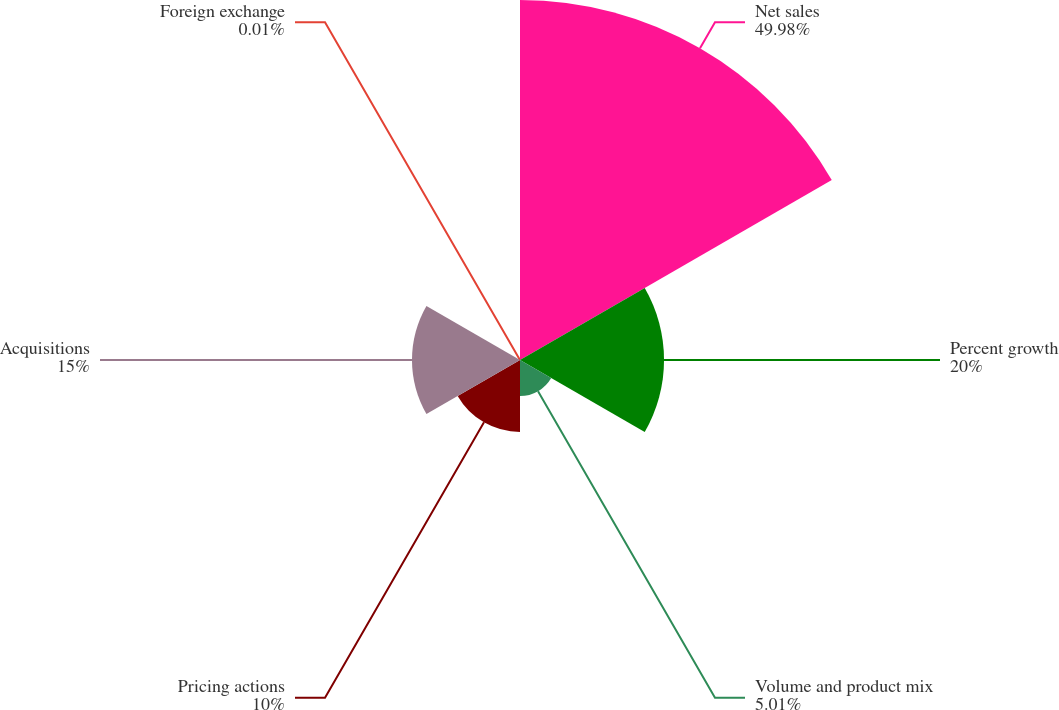<chart> <loc_0><loc_0><loc_500><loc_500><pie_chart><fcel>Net sales<fcel>Percent growth<fcel>Volume and product mix<fcel>Pricing actions<fcel>Acquisitions<fcel>Foreign exchange<nl><fcel>49.99%<fcel>20.0%<fcel>5.01%<fcel>10.0%<fcel>15.0%<fcel>0.01%<nl></chart> 